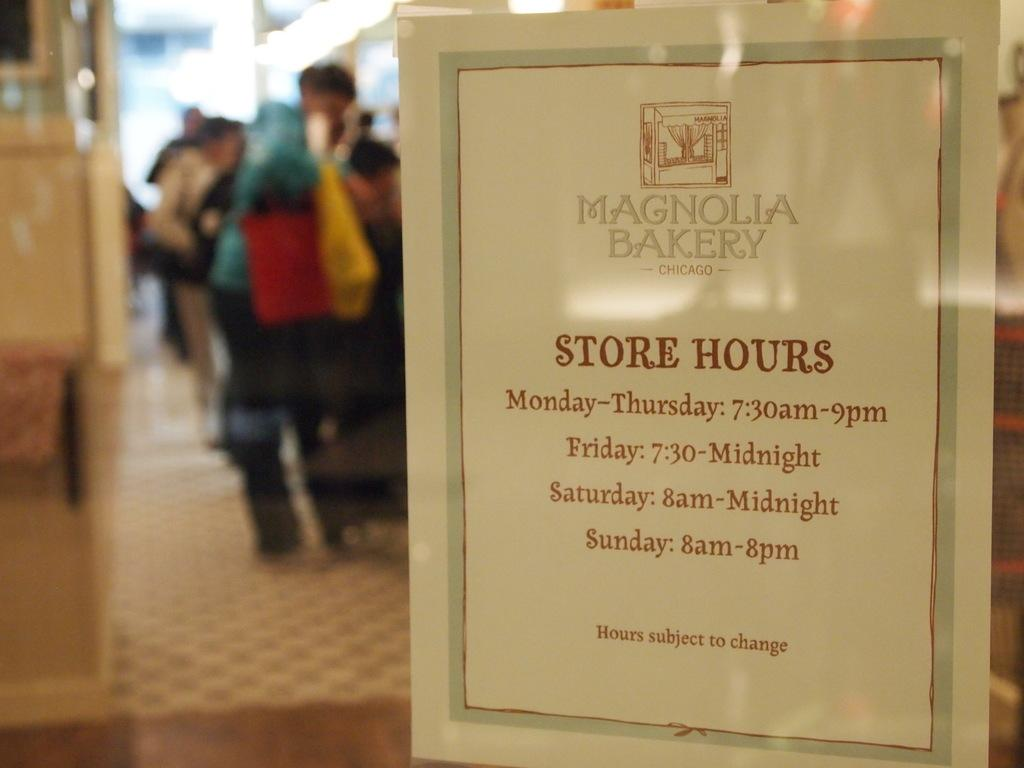<image>
Relay a brief, clear account of the picture shown. A PAPER DISPLAYED ON A STORE FRONT WINDOW THAT SHOW STORE HOURS 